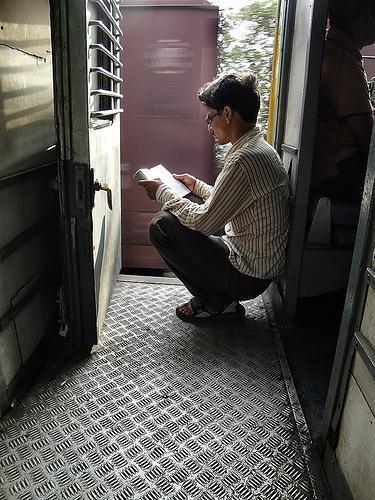How many people?
Give a very brief answer. 1. 